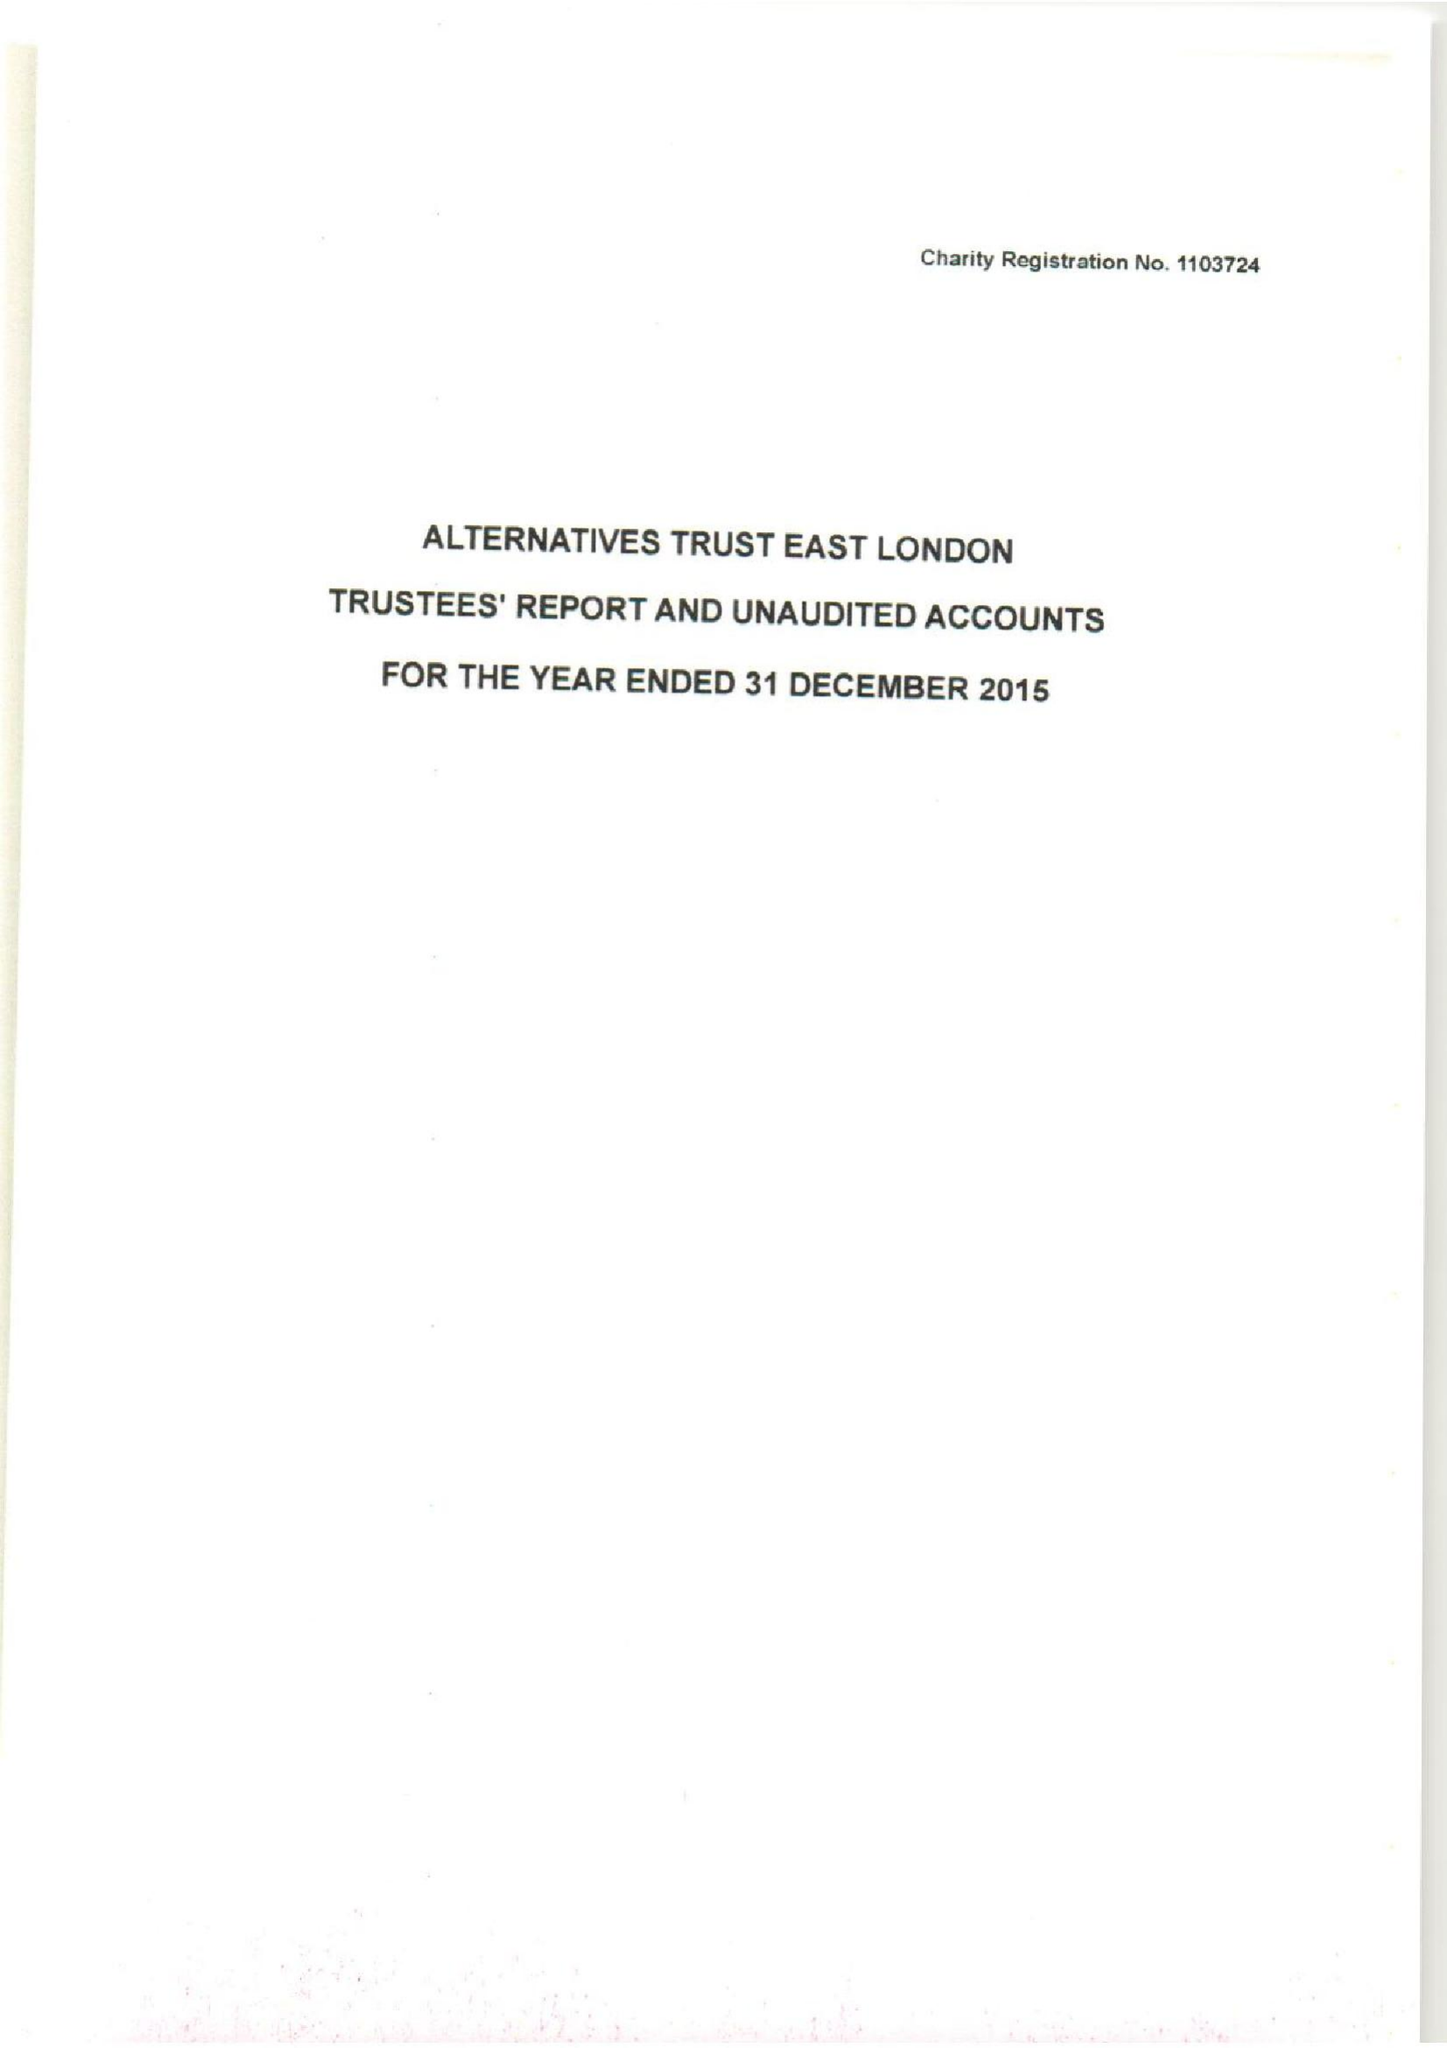What is the value for the charity_name?
Answer the question using a single word or phrase. Alternatives Trust East London 